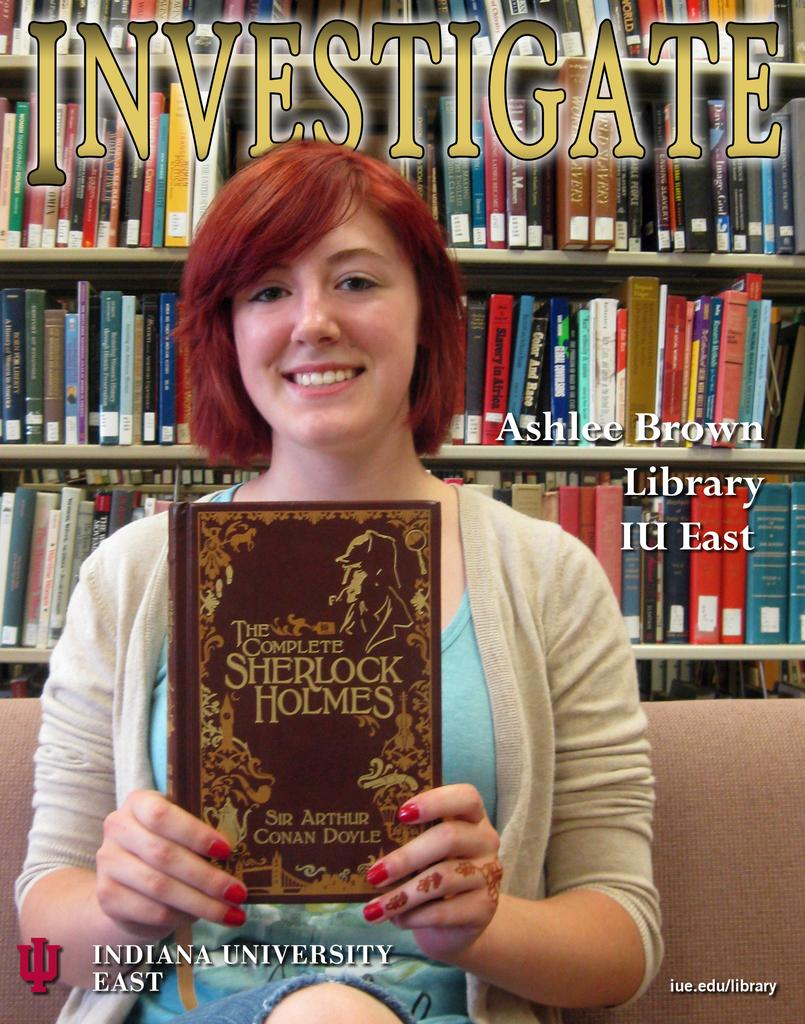<image>
Describe the image concisely. A girl on the cover of a magazine holding a Sherlock Holmes book. 